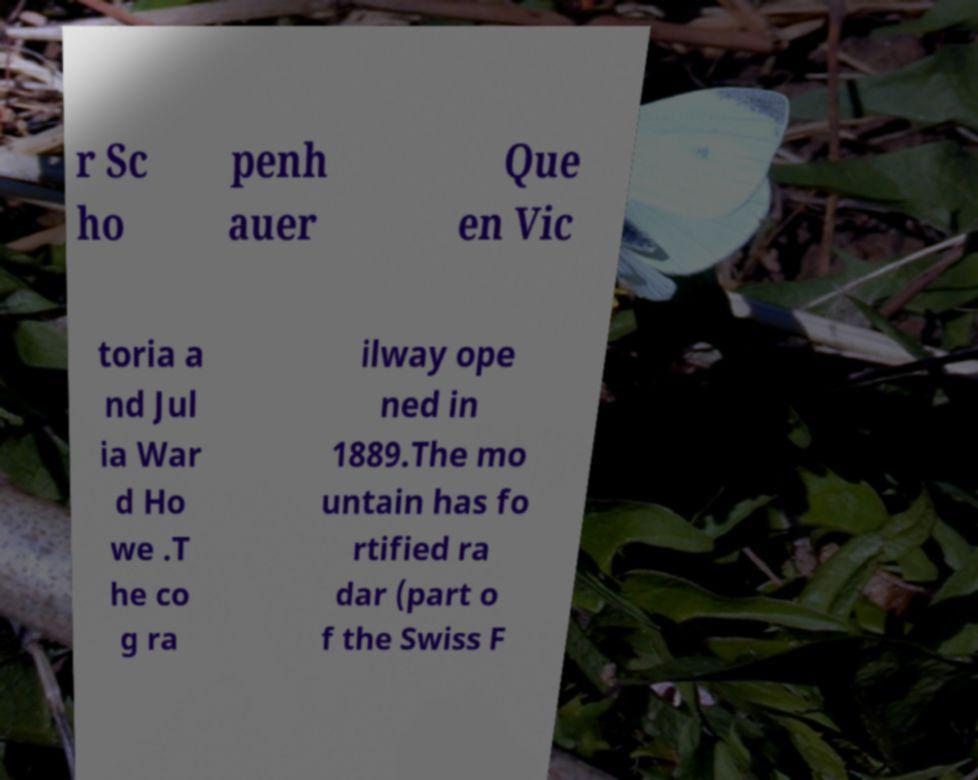What messages or text are displayed in this image? I need them in a readable, typed format. r Sc ho penh auer Que en Vic toria a nd Jul ia War d Ho we .T he co g ra ilway ope ned in 1889.The mo untain has fo rtified ra dar (part o f the Swiss F 